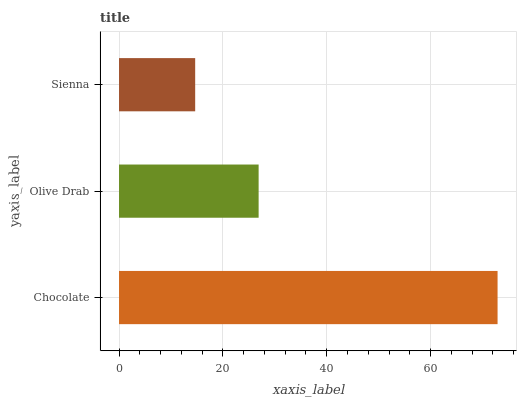Is Sienna the minimum?
Answer yes or no. Yes. Is Chocolate the maximum?
Answer yes or no. Yes. Is Olive Drab the minimum?
Answer yes or no. No. Is Olive Drab the maximum?
Answer yes or no. No. Is Chocolate greater than Olive Drab?
Answer yes or no. Yes. Is Olive Drab less than Chocolate?
Answer yes or no. Yes. Is Olive Drab greater than Chocolate?
Answer yes or no. No. Is Chocolate less than Olive Drab?
Answer yes or no. No. Is Olive Drab the high median?
Answer yes or no. Yes. Is Olive Drab the low median?
Answer yes or no. Yes. Is Chocolate the high median?
Answer yes or no. No. Is Sienna the low median?
Answer yes or no. No. 